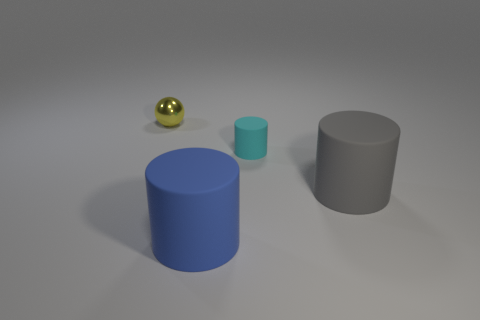Subtract all tiny cyan matte cylinders. How many cylinders are left? 2 Add 2 yellow metallic cubes. How many objects exist? 6 Subtract all cyan cylinders. How many cylinders are left? 2 Subtract 2 cylinders. How many cylinders are left? 1 Subtract all green cylinders. Subtract all cyan spheres. How many cylinders are left? 3 Subtract all red shiny objects. Subtract all blue things. How many objects are left? 3 Add 4 metal things. How many metal things are left? 5 Add 3 tiny spheres. How many tiny spheres exist? 4 Subtract 0 purple spheres. How many objects are left? 4 Subtract all spheres. How many objects are left? 3 